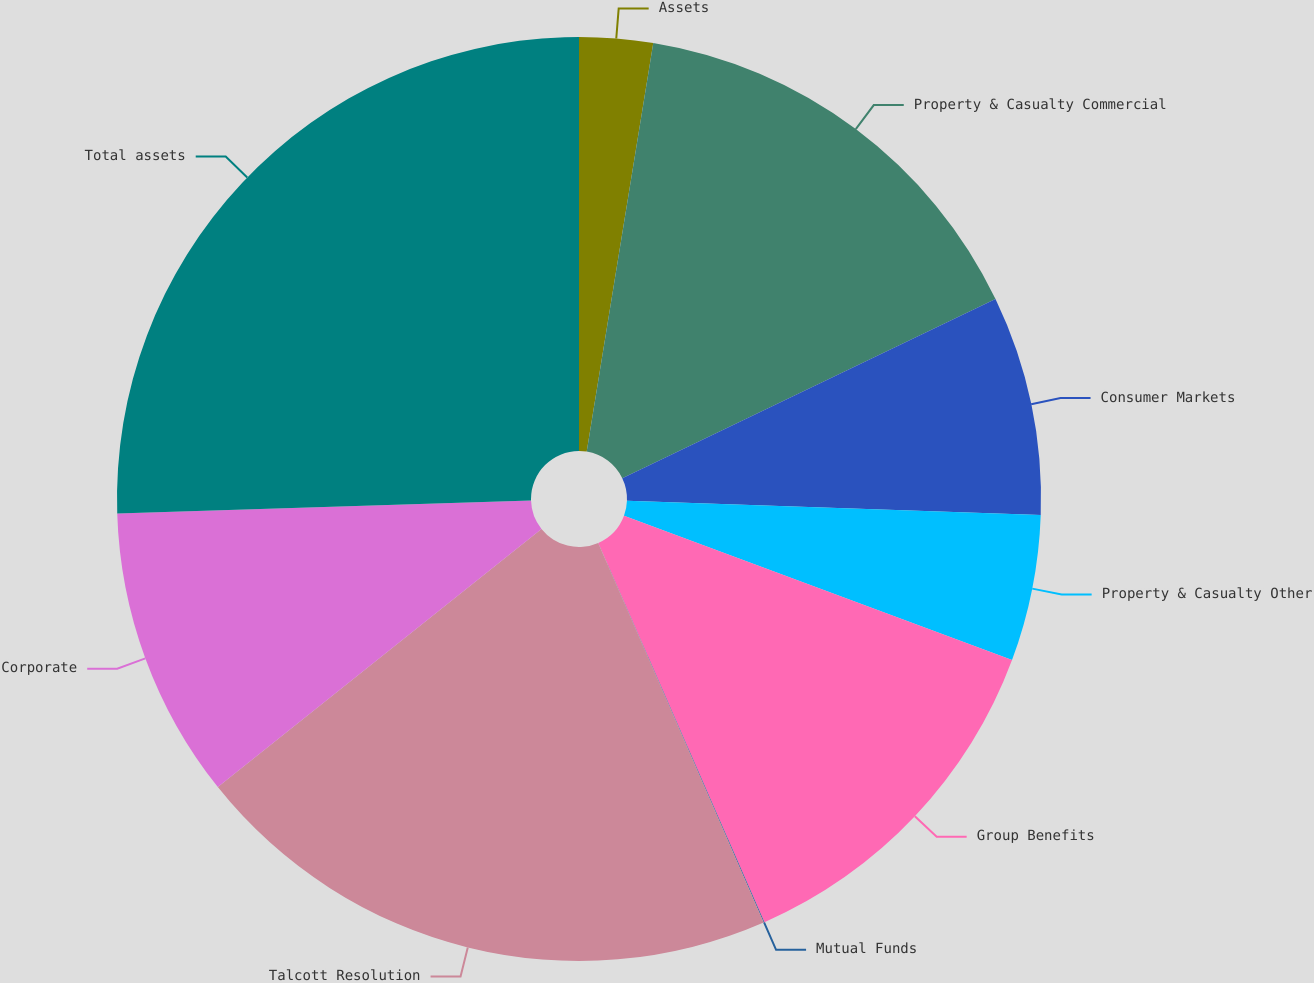<chart> <loc_0><loc_0><loc_500><loc_500><pie_chart><fcel>Assets<fcel>Property & Casualty Commercial<fcel>Consumer Markets<fcel>Property & Casualty Other<fcel>Group Benefits<fcel>Mutual Funds<fcel>Talcott Resolution<fcel>Corporate<fcel>Total assets<nl><fcel>2.57%<fcel>15.31%<fcel>7.67%<fcel>5.12%<fcel>12.76%<fcel>0.03%<fcel>20.83%<fcel>10.22%<fcel>25.5%<nl></chart> 